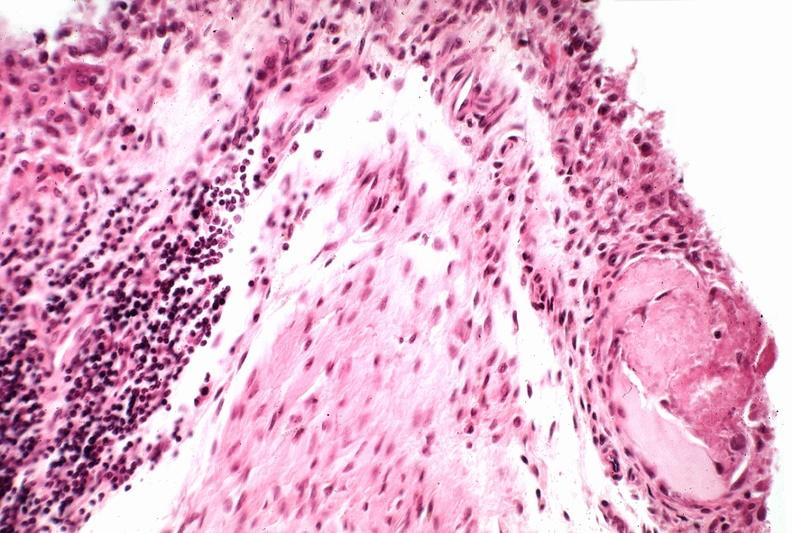s joints present?
Answer the question using a single word or phrase. Yes 